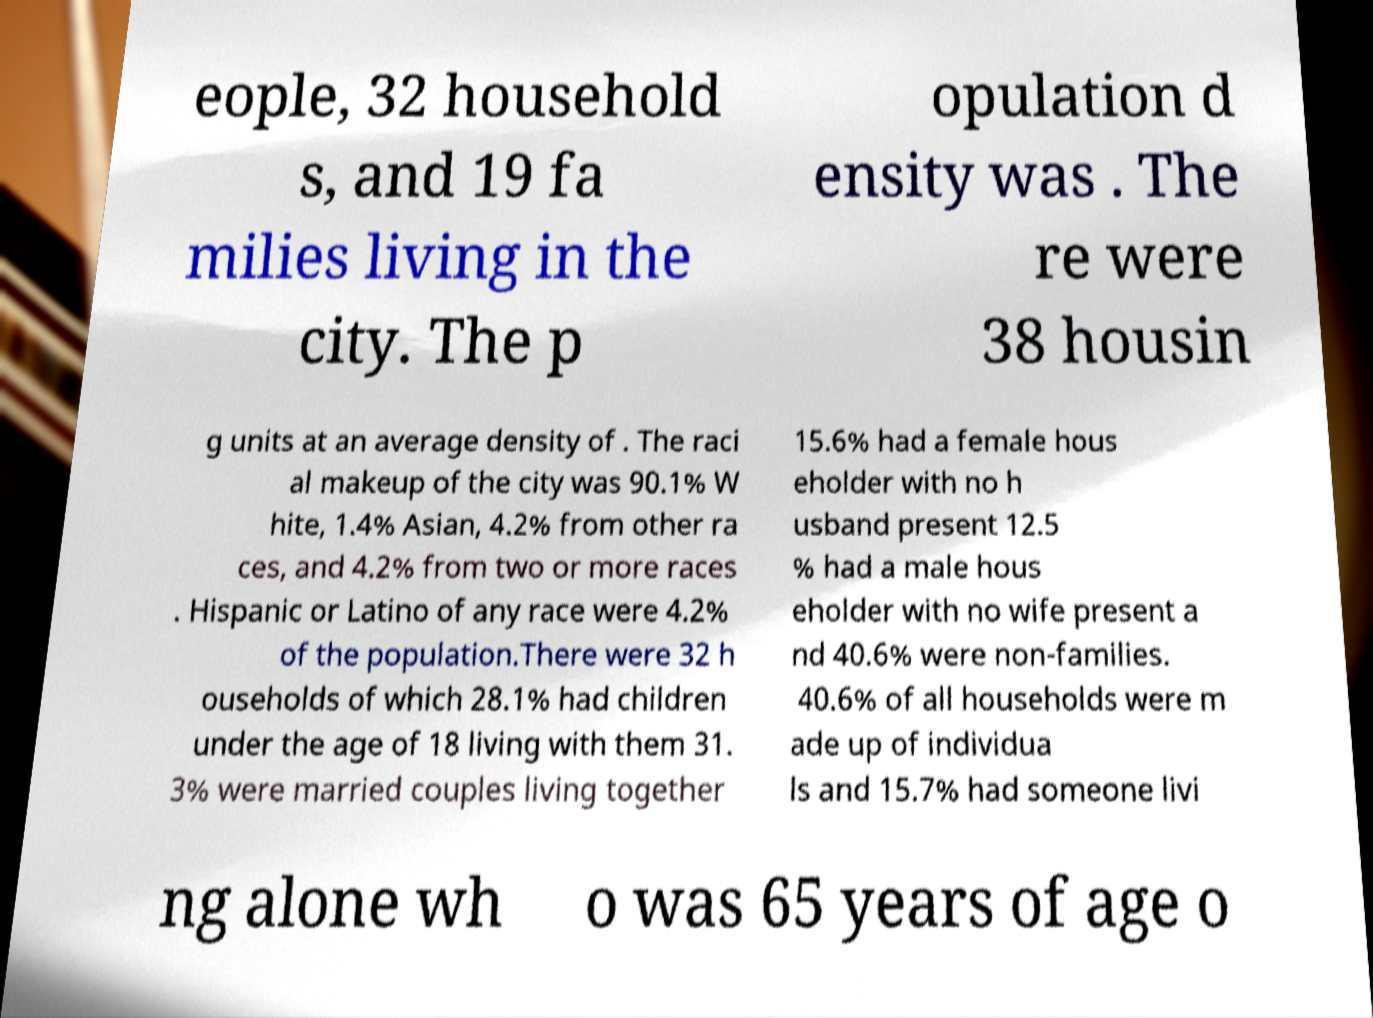Can you read and provide the text displayed in the image?This photo seems to have some interesting text. Can you extract and type it out for me? eople, 32 household s, and 19 fa milies living in the city. The p opulation d ensity was . The re were 38 housin g units at an average density of . The raci al makeup of the city was 90.1% W hite, 1.4% Asian, 4.2% from other ra ces, and 4.2% from two or more races . Hispanic or Latino of any race were 4.2% of the population.There were 32 h ouseholds of which 28.1% had children under the age of 18 living with them 31. 3% were married couples living together 15.6% had a female hous eholder with no h usband present 12.5 % had a male hous eholder with no wife present a nd 40.6% were non-families. 40.6% of all households were m ade up of individua ls and 15.7% had someone livi ng alone wh o was 65 years of age o 